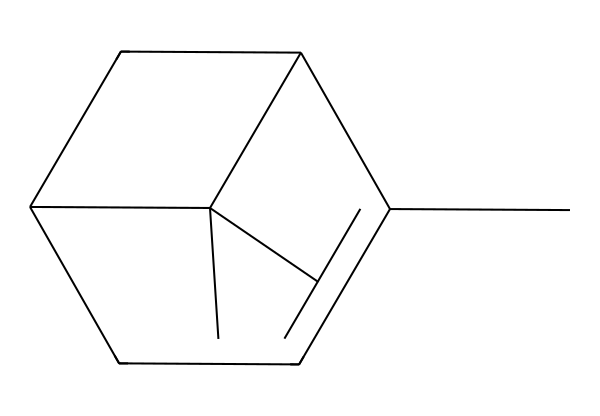What is the molecular formula of α-pinene? The given SMILES representation can be interpreted to count the carbon (C) and hydrogen (H) atoms. The structure indicates a total of 10 carbon atoms and 16 hydrogen atoms, leading to the molecular formula C10H16.
Answer: C10H16 How many rings are in α-pinene? By analyzing the structure from the SMILES, there are two cycles indicated by the "C" and "C" connections as well as the numbers that signify ring closures. Counting these, we find there are 2 rings in the structure.
Answer: 2 What kind of functional group is primarily present in α-pinene? Terpenes like α-pinene primarily feature multiple carbon-carbon bonds; visual inspection shows that there are no heteroatoms or functional groups other than C and H, thus confirming α-pinene is primarily made up of hydrocarbons.
Answer: hydrocarbons What is the main characteristic of α-pinene's aroma? As a terpene, α-pinene is known for its fresh, pine-like aroma. This characteristic is attributed to its specific molecular structure that interacts with scent receptors effectively.
Answer: pine-like Does α-pinene have a chiral center? A chiral center is identified by the presence of a carbon atom bonded to four different substituents. By examining the structure, it’s evident that there are no such carbons in α-pinene, indicating it does not have a chiral center.
Answer: no What is the boiling point of α-pinene? The boiling point of α-pinene is a property not deduced from the SMILES directly, but it is known in literature to be around 156 degrees Celsius due to its molecular weight and structure.
Answer: 156°C 